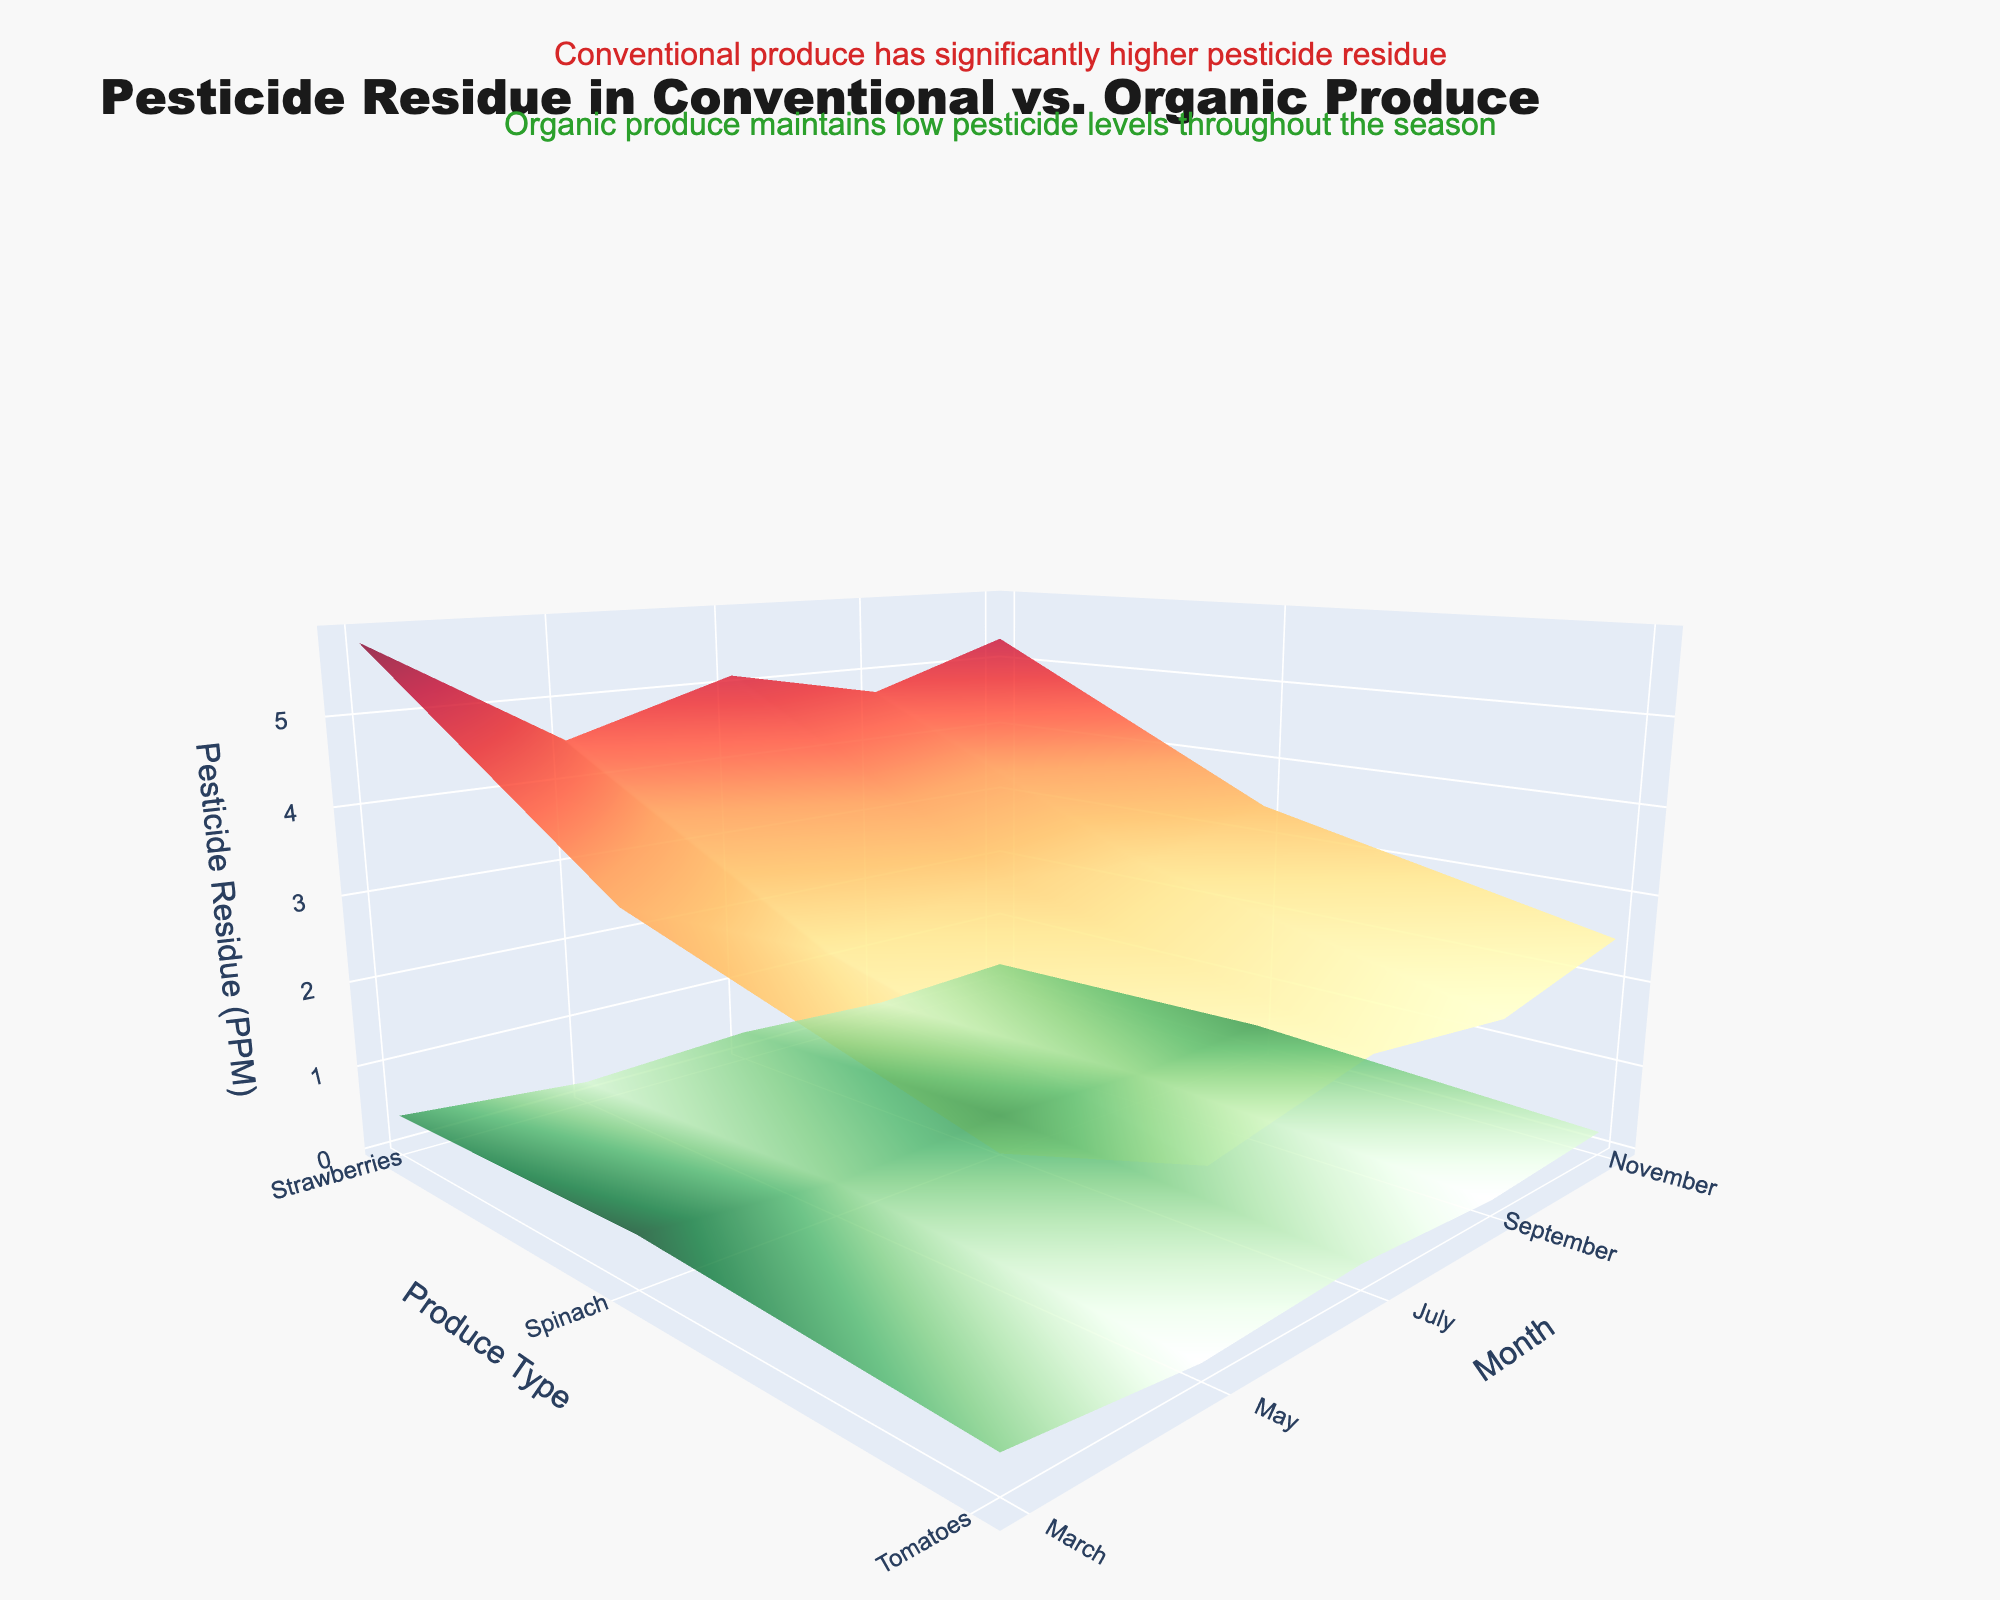What is the title of the 3D surface plot? Look at the top of the figure where the title is located.
Answer: Pesticide Residue in Conventional vs. Organic Produce Which produce shows the highest pesticide residue in conventional farming in July? Identify the highest peak in July in the red-colored surface, which represents conventional farming. The peak will correspond to the produce type.
Answer: Spinach How do the pesticide residue levels in organic strawberries change from March to November? Track the green-colored surface representing organic produce residues for strawberries across the months. Observe the trend from March to November.
Answer: It increases slightly from 0.3 to 0.3 In which month is the difference in pesticide residue between conventional and organic spinach the greatest? Calculate the differences between the conventional and organic residues for spinach for each month. Identify the month with the largest difference.
Answer: July What is the overall trend in pesticide residues for organic tomatoes across the growing season? Examine the green-colored surface representing organic pesticide residues for tomatoes and observe the trend from March to November.
Answer: The residue levels increase slightly from 0.1 to 0.1 Which month has the lowest pesticide residue for conventional strawberries? Identify the lowest point on the red-colored surface for strawberries and note the corresponding month.
Answer: March How does the pesticide residue in conventional tomatoes in November compare to organic tomatoes in the same month? Compare the heights of the surfaces representing conventional (red) and organic (green) residues for tomatoes in November.
Answer: Conventional is higher than organic What can you infer about pesticide residue levels in organic produce throughout the season? Observe the green-colored surface across all produce types and months to determine the trend or pattern.
Answer: They remain consistently low Between strawberries, spinach, and tomatoes, which has the highest overall pesticide residue in conventional farming? Look at the heights of the red-colored surface for all three produce types and identify the one with the highest levels overall.
Answer: Spinach Is there any month where the pesticide residue levels for both conventional and organic farming are equal for any produce type? Compare both the red and green surfaces for each produce type across all months and see if any coincide.
Answer: No 